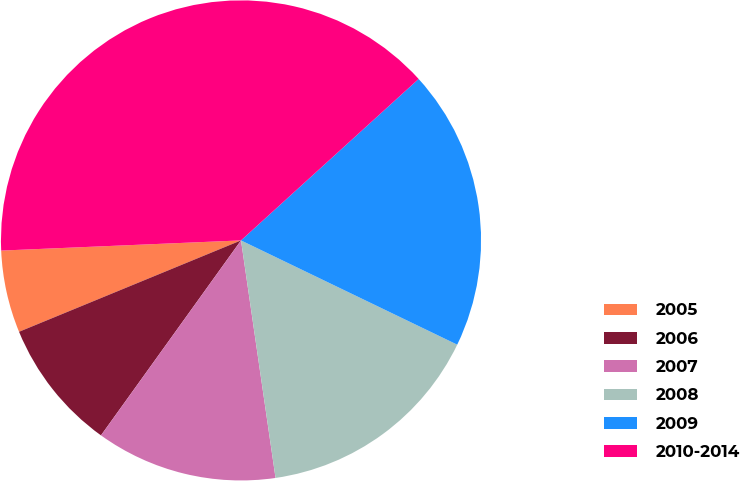Convert chart. <chart><loc_0><loc_0><loc_500><loc_500><pie_chart><fcel>2005<fcel>2006<fcel>2007<fcel>2008<fcel>2009<fcel>2010-2014<nl><fcel>5.54%<fcel>8.87%<fcel>12.21%<fcel>15.55%<fcel>18.89%<fcel>38.93%<nl></chart> 